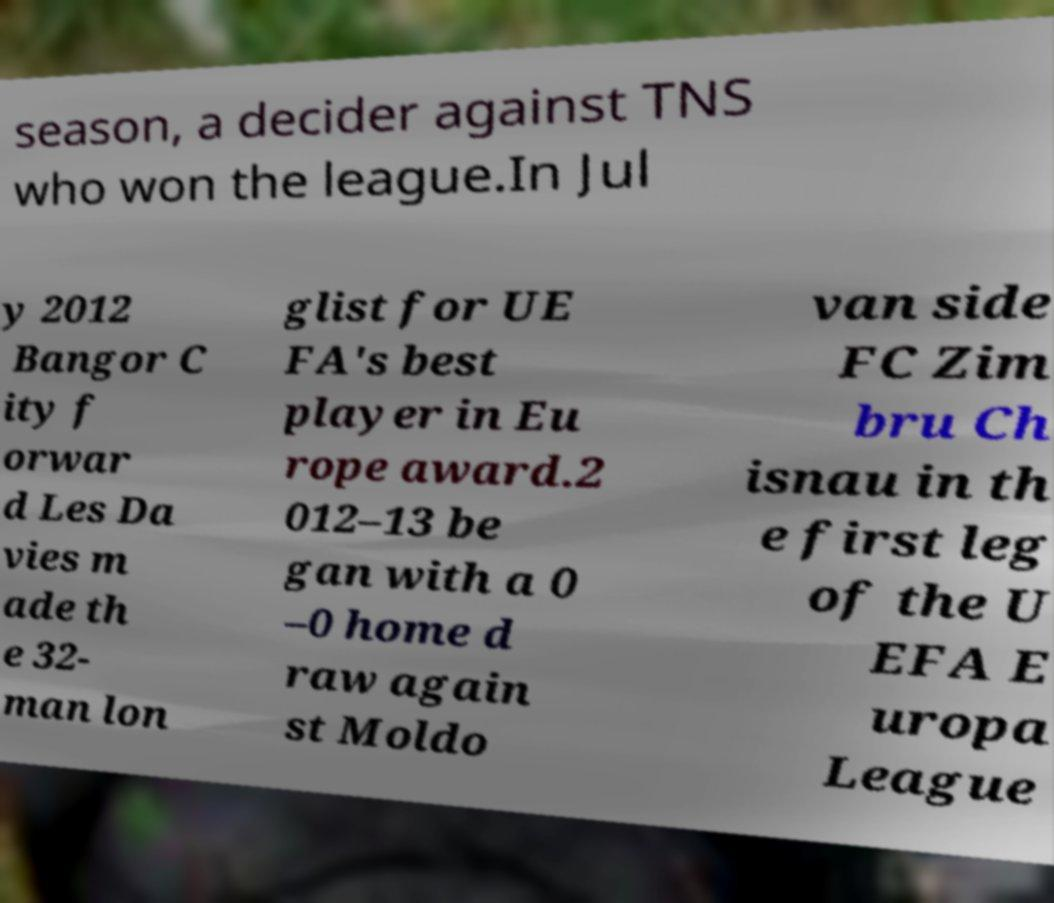Could you assist in decoding the text presented in this image and type it out clearly? season, a decider against TNS who won the league.In Jul y 2012 Bangor C ity f orwar d Les Da vies m ade th e 32- man lon glist for UE FA's best player in Eu rope award.2 012–13 be gan with a 0 –0 home d raw again st Moldo van side FC Zim bru Ch isnau in th e first leg of the U EFA E uropa League 